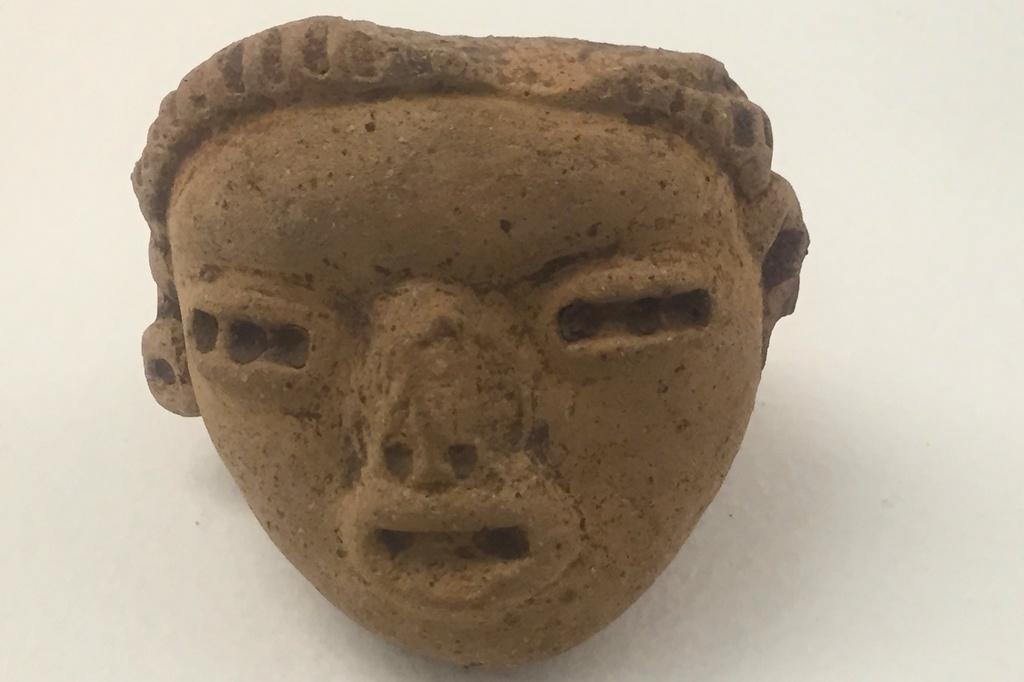What is the main subject of the image? The main subject of the image is a face sculpture. Where is the face sculpture located in the image? The face sculpture is in the front of the image. What can be seen in the background of the image? There appears to be a wall in the background of the image. How many legs can be seen supporting the face sculpture in the image? There are no legs visible in the image, as the face sculpture is likely mounted or placed on a surface. 